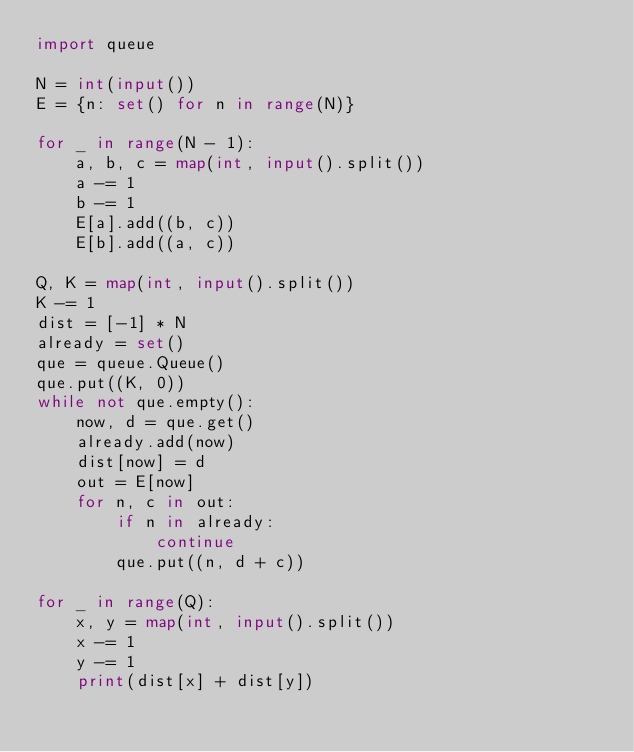Convert code to text. <code><loc_0><loc_0><loc_500><loc_500><_Python_>import queue

N = int(input())
E = {n: set() for n in range(N)}

for _ in range(N - 1):
    a, b, c = map(int, input().split())
    a -= 1
    b -= 1
    E[a].add((b, c))
    E[b].add((a, c))

Q, K = map(int, input().split())
K -= 1
dist = [-1] * N
already = set()
que = queue.Queue()
que.put((K, 0))
while not que.empty():
    now, d = que.get()
    already.add(now)
    dist[now] = d
    out = E[now]
    for n, c in out:
        if n in already:
            continue
        que.put((n, d + c))

for _ in range(Q):
    x, y = map(int, input().split())
    x -= 1
    y -= 1
    print(dist[x] + dist[y])
</code> 